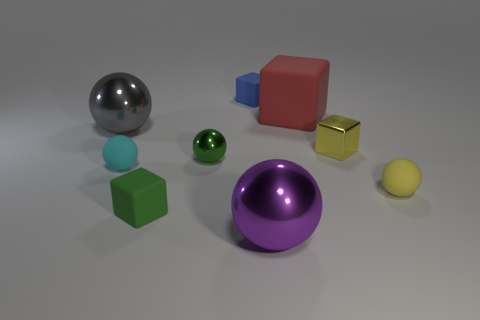Subtract all red cubes. How many cubes are left? 3 Subtract all small yellow spheres. How many spheres are left? 4 Add 1 cyan rubber things. How many objects exist? 10 Subtract all green cubes. Subtract all red spheres. How many cubes are left? 3 Subtract all balls. How many objects are left? 4 Add 8 large purple metal things. How many large purple metal things exist? 9 Subtract 1 cyan spheres. How many objects are left? 8 Subtract all blue blocks. Subtract all green cubes. How many objects are left? 7 Add 6 metallic things. How many metallic things are left? 10 